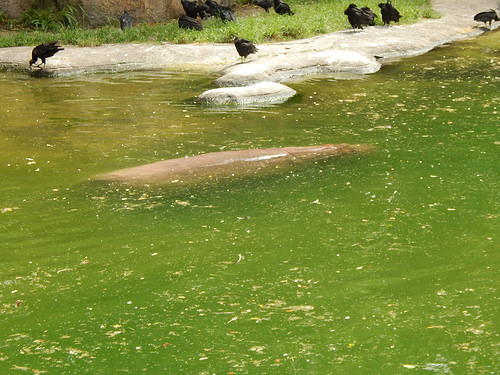<image>
Is the rock on the water? Yes. Looking at the image, I can see the rock is positioned on top of the water, with the water providing support. 